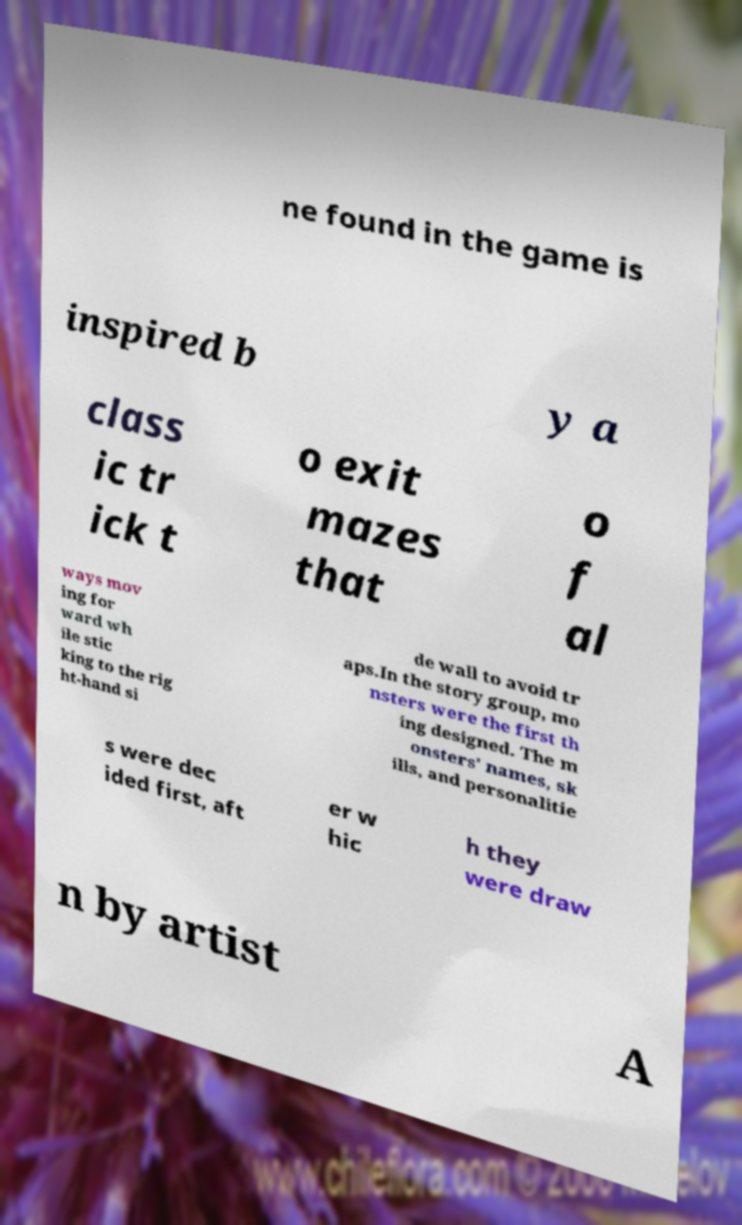Please read and relay the text visible in this image. What does it say? ne found in the game is inspired b y a class ic tr ick t o exit mazes that o f al ways mov ing for ward wh ile stic king to the rig ht-hand si de wall to avoid tr aps.In the story group, mo nsters were the first th ing designed. The m onsters' names, sk ills, and personalitie s were dec ided first, aft er w hic h they were draw n by artist A 